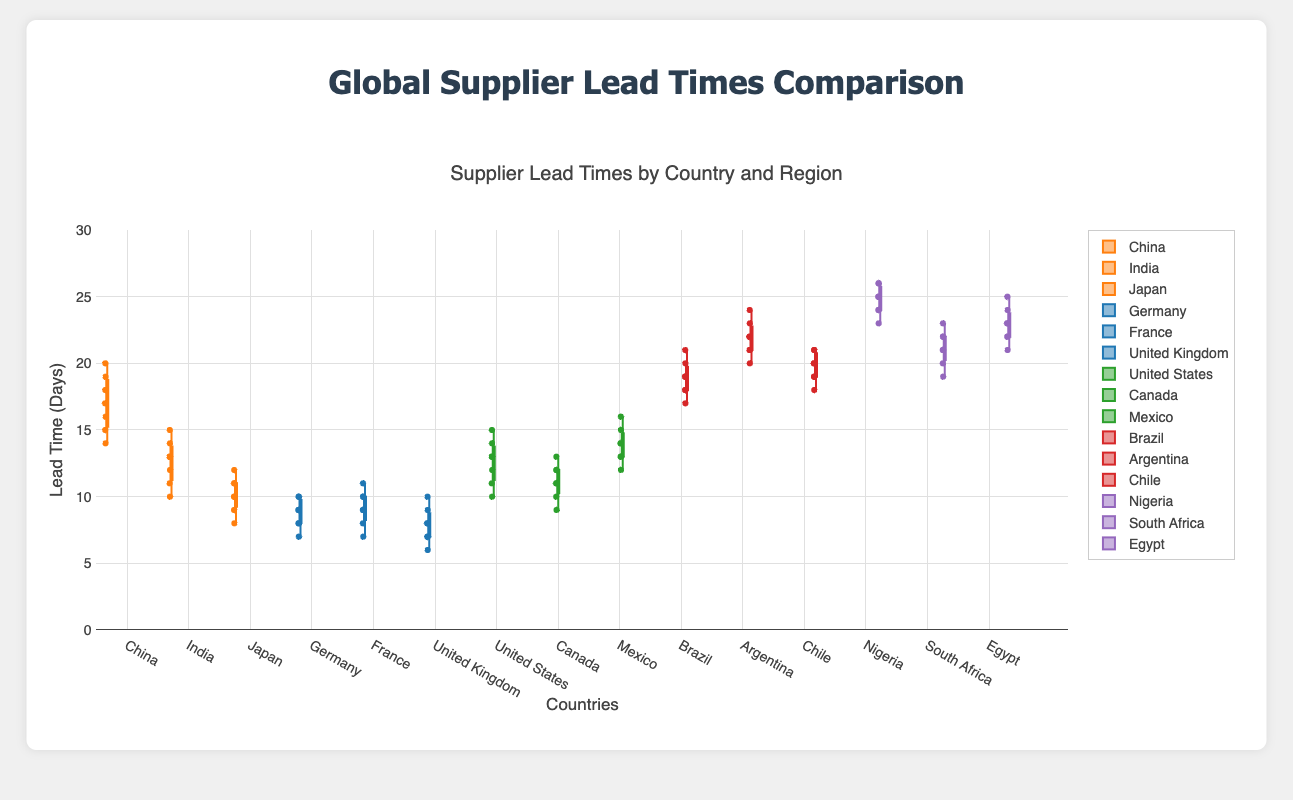What is the title of the figure? The title of the figure is displayed at the top and it describes the data represented in the plot.
Answer: Global Supplier Lead Times Comparison Which country in Asia has the highest median lead time? Among the countries in Asia, the median lead time for each country can be identified on the box plot by looking at the horizontal line inside each box. The highest median in Asia is for China.
Answer: China What is the range of lead times for suppliers in the United Kingdom? The range of lead times is the distance between the minimum and maximum values within the whiskers of the box plot for the United Kingdom. The minimum value is 6 and the maximum value is 10.
Answer: 4 days Which region has the country with the highest maximum lead time? The region with the country that has the highest maximum lead time can be found by comparing the upper whiskers of the box plots of all countries. The highest maximum lead time is for Argentina in South America.
Answer: South America What is the interquartile range (IQR) for suppliers in Japan? The IQR is the distance between the first quartile (lower edge of the box) and the third quartile (upper edge of the box) in the box plot for Japan. From the plot, the lower quartile is 9 and the upper quartile is 11.
Answer: 2 days Compare the median lead times between North America and Africa. Which region has the higher median? By examining the median lines within the boxes, the median lead times for North America and Africa can be compared. The countries in Africa (21-25 days) have a higher median than those in North America (10-14 days).
Answer: Africa What country in Europe has the smallest spread of lead times? The country with the smallest spread of lead times has the smallest distance between the minimum and maximum whiskers. Germany has the smallest spread when compared to France and the United Kingdom.
Answer: Germany Identify the country in South America with the highest median lead time. The country with the highest median lead time in South America can be identified by the position of the median line in the box plots of Brazil, Argentina, and Chile. Argentina has the highest median.
Answer: Argentina Is there a region where the lead times of one country are consistently higher than those in Europe? To determine this, compare the highest interquartile ranges and medians of one country across different regions with those in Europe. Nigeria in Africa consistently has higher lead times than any country in Europe.
Answer: Yes, Africa How does the lead time variability of suppliers in Canada compare to suppliers in Japan? The variability in lead times can be assessed by comparing the lengths of the boxes and whiskers of the box plots for Canada and Japan. Canada's box and whiskers show a greater spread than Japan's.
Answer: Canada shows greater variability 